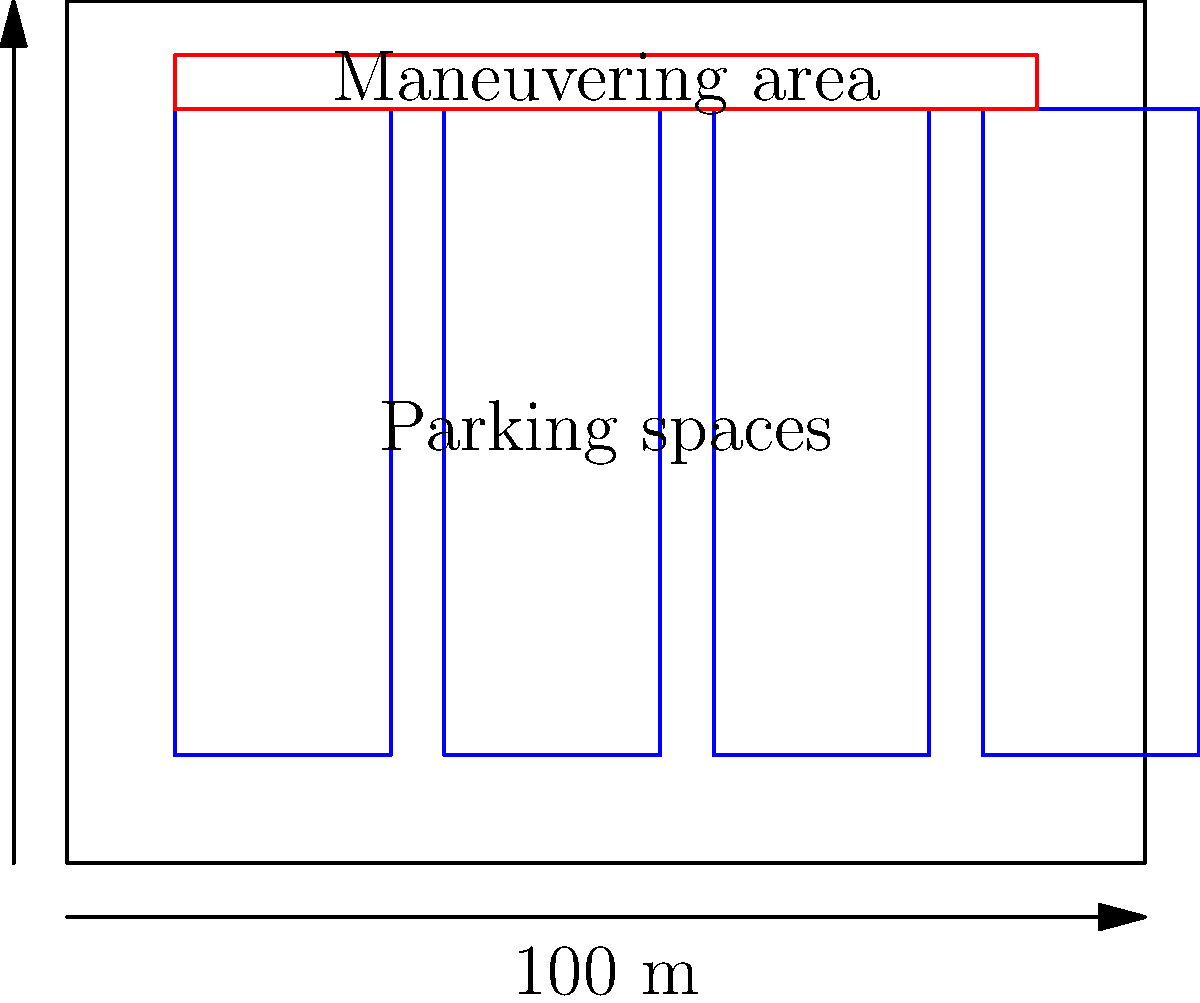In designing a fire station layout, you need to optimize the space for fire truck parking and maneuvering. Given a rectangular fire station with dimensions 100 m × 80 m, what is the minimum width of the maneuvering area required to allow fire trucks to safely exit their parking spaces, assuming each truck requires a 20 m × 60 m parking space and a turning radius of 15 m? To determine the minimum width of the maneuvering area, we need to consider the following steps:

1. Analyze the given dimensions:
   - Fire station: 100 m × 80 m
   - Each truck parking space: 20 m × 60 m
   - Truck turning radius: 15 m

2. Calculate the space available for maneuvering:
   - Total height of station: 80 m
   - Height occupied by parking spaces: 60 m
   - Remaining space: 80 m - 60 m = 20 m

3. Consider the turning radius:
   - The trucks need a minimum of 15 m radius to turn
   - This translates to a 30 m diameter circle

4. Determine the minimum maneuvering width:
   - The maneuvering area should be wide enough to accommodate the turning diameter
   - Minimum width = 30 m

5. Compare with available space:
   - Available space (20 m) < Minimum required (30 m)

6. Adjust the layout:
   - Reduce parking space height to 55 m
   - New available space: 80 m - 55 m = 25 m

7. Final calculation:
   - Minimum maneuvering width = 25 m
   - This allows for the 15 m turning radius while maximizing parking space

Therefore, the minimum width of the maneuvering area should be 25 m to allow safe exiting of fire trucks while optimizing the use of available space.
Answer: 25 m 